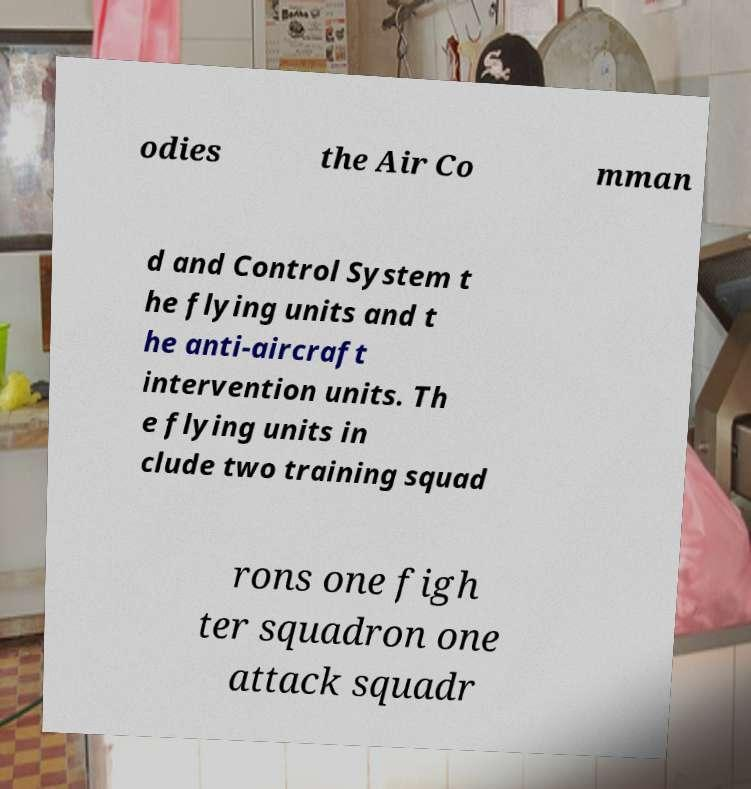Could you assist in decoding the text presented in this image and type it out clearly? odies the Air Co mman d and Control System t he flying units and t he anti-aircraft intervention units. Th e flying units in clude two training squad rons one figh ter squadron one attack squadr 